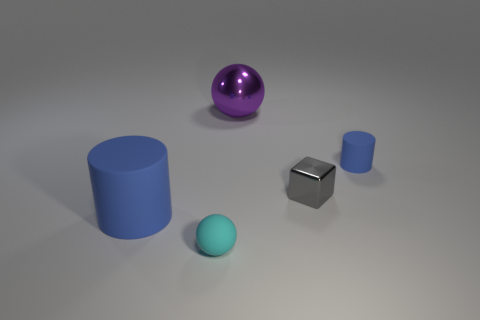How could these objects be used in a learning environment? These objects could be very effective as educational tools in a learning environment focusing on geometry and spatial awareness. For example, they can help students understand concepts such as volume, surface area, and the properties of different shapes. Additionally, the reflection and textures can be used to discuss light properties and material science. 